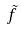<formula> <loc_0><loc_0><loc_500><loc_500>\tilde { f }</formula> 